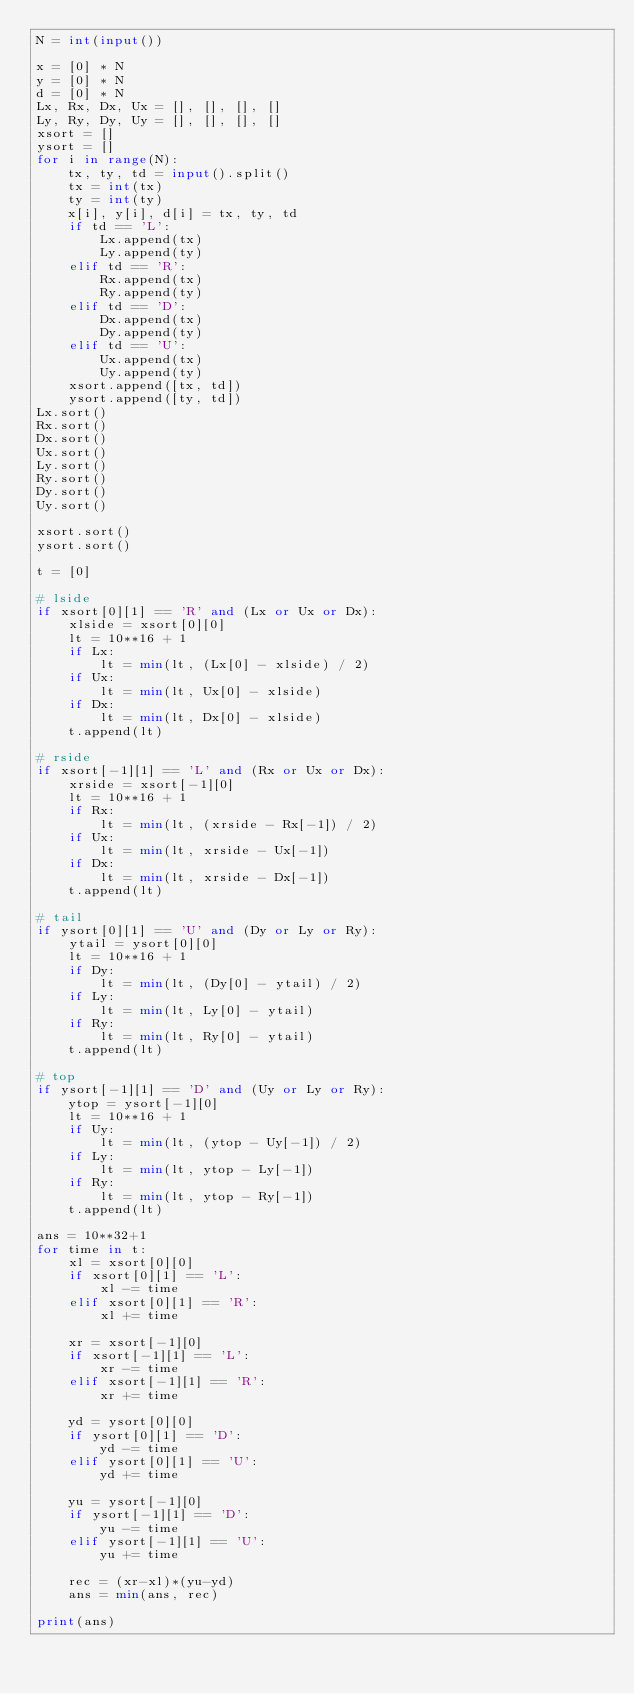Convert code to text. <code><loc_0><loc_0><loc_500><loc_500><_Python_>N = int(input())

x = [0] * N
y = [0] * N
d = [0] * N
Lx, Rx, Dx, Ux = [], [], [], []
Ly, Ry, Dy, Uy = [], [], [], []
xsort = []
ysort = []
for i in range(N):
    tx, ty, td = input().split()
    tx = int(tx)
    ty = int(ty)
    x[i], y[i], d[i] = tx, ty, td
    if td == 'L':
        Lx.append(tx)
        Ly.append(ty)
    elif td == 'R':
        Rx.append(tx)
        Ry.append(ty)
    elif td == 'D':
        Dx.append(tx)
        Dy.append(ty)
    elif td == 'U':
        Ux.append(tx)
        Uy.append(ty)
    xsort.append([tx, td])
    ysort.append([ty, td])
Lx.sort()
Rx.sort()
Dx.sort()
Ux.sort()
Ly.sort()
Ry.sort()
Dy.sort()
Uy.sort()

xsort.sort()
ysort.sort()

t = [0]

# lside
if xsort[0][1] == 'R' and (Lx or Ux or Dx):
    xlside = xsort[0][0]
    lt = 10**16 + 1
    if Lx:
        lt = min(lt, (Lx[0] - xlside) / 2)
    if Ux:
        lt = min(lt, Ux[0] - xlside)
    if Dx:
        lt = min(lt, Dx[0] - xlside)
    t.append(lt)

# rside
if xsort[-1][1] == 'L' and (Rx or Ux or Dx):
    xrside = xsort[-1][0]
    lt = 10**16 + 1
    if Rx:
        lt = min(lt, (xrside - Rx[-1]) / 2)
    if Ux:
        lt = min(lt, xrside - Ux[-1])
    if Dx:
        lt = min(lt, xrside - Dx[-1])
    t.append(lt)

# tail
if ysort[0][1] == 'U' and (Dy or Ly or Ry):
    ytail = ysort[0][0]
    lt = 10**16 + 1
    if Dy:
        lt = min(lt, (Dy[0] - ytail) / 2)
    if Ly:
        lt = min(lt, Ly[0] - ytail)
    if Ry:
        lt = min(lt, Ry[0] - ytail)
    t.append(lt)

# top
if ysort[-1][1] == 'D' and (Uy or Ly or Ry):
    ytop = ysort[-1][0]
    lt = 10**16 + 1
    if Uy:
        lt = min(lt, (ytop - Uy[-1]) / 2)
    if Ly:
        lt = min(lt, ytop - Ly[-1])
    if Ry:
        lt = min(lt, ytop - Ry[-1])
    t.append(lt)

ans = 10**32+1
for time in t:
    xl = xsort[0][0]
    if xsort[0][1] == 'L':
        xl -= time
    elif xsort[0][1] == 'R':
        xl += time

    xr = xsort[-1][0]
    if xsort[-1][1] == 'L':
        xr -= time
    elif xsort[-1][1] == 'R':
        xr += time

    yd = ysort[0][0]
    if ysort[0][1] == 'D':
        yd -= time
    elif ysort[0][1] == 'U':
        yd += time

    yu = ysort[-1][0]
    if ysort[-1][1] == 'D':
        yu -= time
    elif ysort[-1][1] == 'U':
        yu += time

    rec = (xr-xl)*(yu-yd)
    ans = min(ans, rec)

print(ans)
</code> 